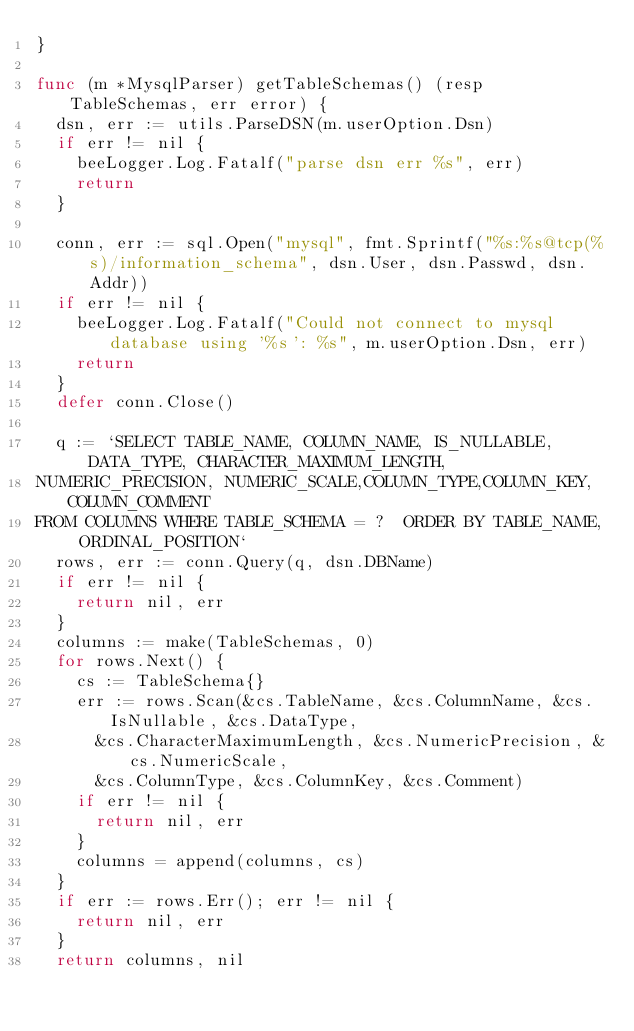Convert code to text. <code><loc_0><loc_0><loc_500><loc_500><_Go_>}

func (m *MysqlParser) getTableSchemas() (resp TableSchemas, err error) {
	dsn, err := utils.ParseDSN(m.userOption.Dsn)
	if err != nil {
		beeLogger.Log.Fatalf("parse dsn err %s", err)
		return
	}

	conn, err := sql.Open("mysql", fmt.Sprintf("%s:%s@tcp(%s)/information_schema", dsn.User, dsn.Passwd, dsn.Addr))
	if err != nil {
		beeLogger.Log.Fatalf("Could not connect to mysql database using '%s': %s", m.userOption.Dsn, err)
		return
	}
	defer conn.Close()

	q := `SELECT TABLE_NAME, COLUMN_NAME, IS_NULLABLE, DATA_TYPE, CHARACTER_MAXIMUM_LENGTH, 
NUMERIC_PRECISION, NUMERIC_SCALE,COLUMN_TYPE,COLUMN_KEY,COLUMN_COMMENT 
FROM COLUMNS WHERE TABLE_SCHEMA = ?  ORDER BY TABLE_NAME, ORDINAL_POSITION`
	rows, err := conn.Query(q, dsn.DBName)
	if err != nil {
		return nil, err
	}
	columns := make(TableSchemas, 0)
	for rows.Next() {
		cs := TableSchema{}
		err := rows.Scan(&cs.TableName, &cs.ColumnName, &cs.IsNullable, &cs.DataType,
			&cs.CharacterMaximumLength, &cs.NumericPrecision, &cs.NumericScale,
			&cs.ColumnType, &cs.ColumnKey, &cs.Comment)
		if err != nil {
			return nil, err
		}
		columns = append(columns, cs)
	}
	if err := rows.Err(); err != nil {
		return nil, err
	}
	return columns, nil</code> 